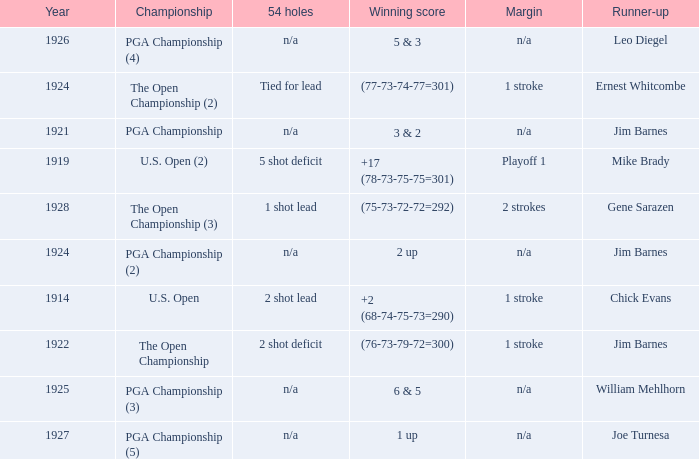In which year did the score stand at 3 & 2? 1921.0. 